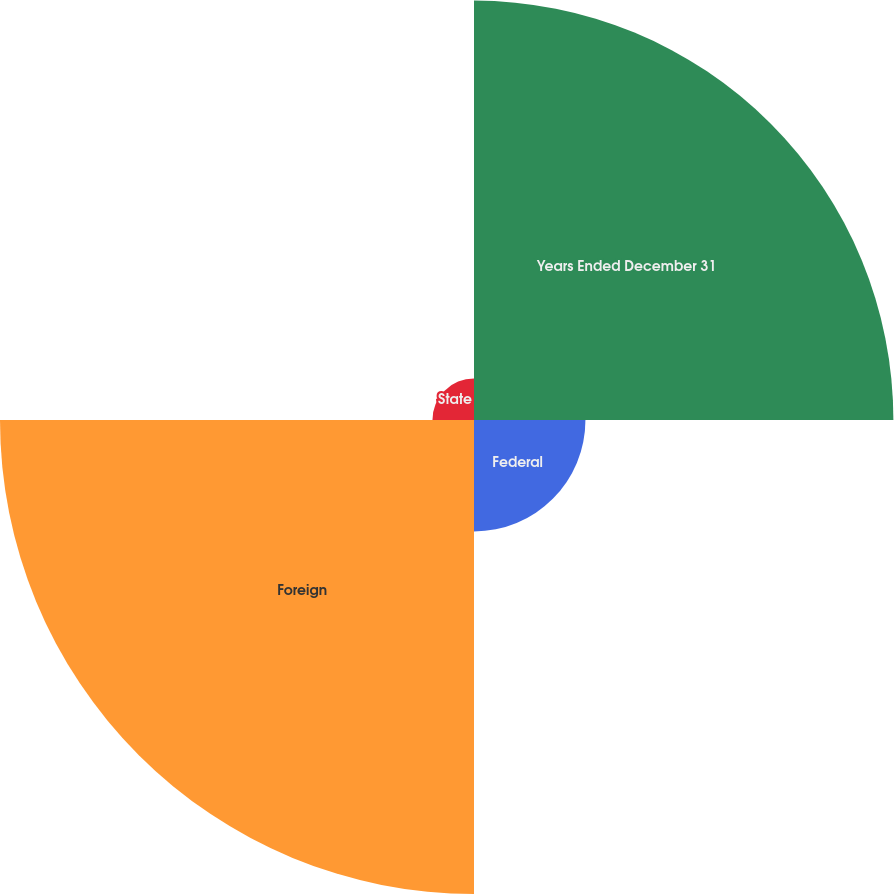Convert chart to OTSL. <chart><loc_0><loc_0><loc_500><loc_500><pie_chart><fcel>Years Ended December 31<fcel>Federal<fcel>Foreign<fcel>State<nl><fcel>40.08%<fcel>10.65%<fcel>45.3%<fcel>3.97%<nl></chart> 